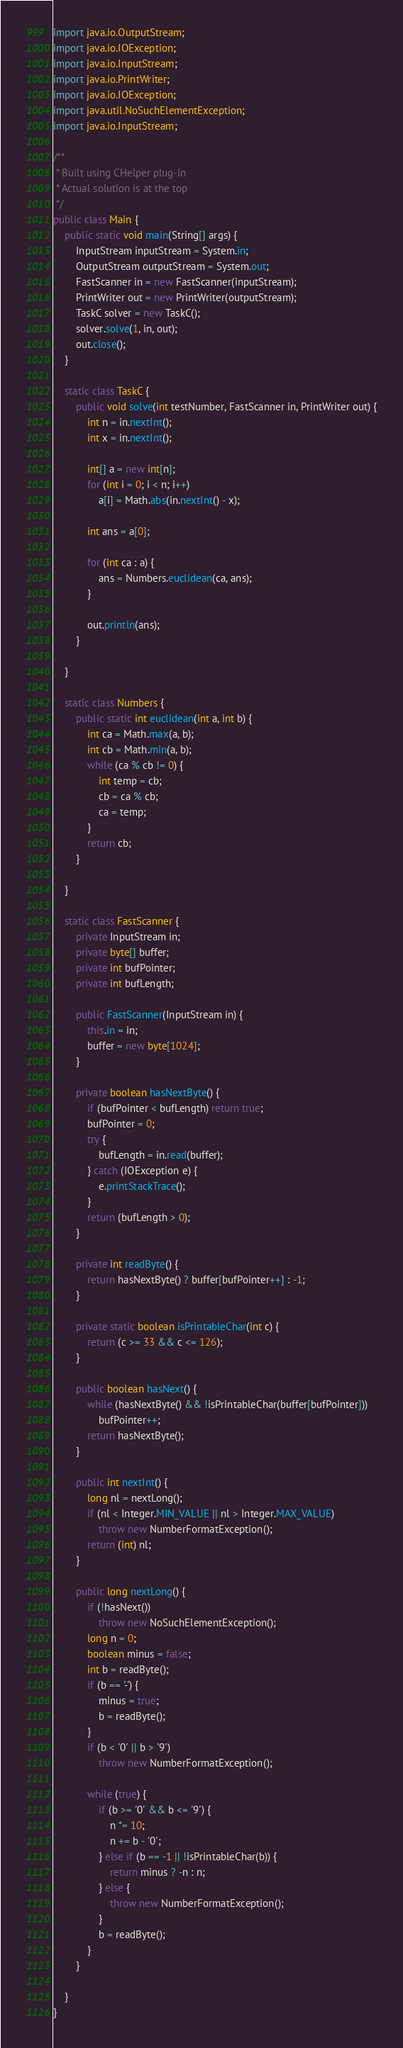<code> <loc_0><loc_0><loc_500><loc_500><_Java_>import java.io.OutputStream;
import java.io.IOException;
import java.io.InputStream;
import java.io.PrintWriter;
import java.io.IOException;
import java.util.NoSuchElementException;
import java.io.InputStream;

/**
 * Built using CHelper plug-in
 * Actual solution is at the top
 */
public class Main {
    public static void main(String[] args) {
        InputStream inputStream = System.in;
        OutputStream outputStream = System.out;
        FastScanner in = new FastScanner(inputStream);
        PrintWriter out = new PrintWriter(outputStream);
        TaskC solver = new TaskC();
        solver.solve(1, in, out);
        out.close();
    }

    static class TaskC {
        public void solve(int testNumber, FastScanner in, PrintWriter out) {
            int n = in.nextInt();
            int x = in.nextInt();

            int[] a = new int[n];
            for (int i = 0; i < n; i++)
                a[i] = Math.abs(in.nextInt() - x);

            int ans = a[0];

            for (int ca : a) {
                ans = Numbers.euclidean(ca, ans);
            }

            out.println(ans);
        }

    }

    static class Numbers {
        public static int euclidean(int a, int b) {
            int ca = Math.max(a, b);
            int cb = Math.min(a, b);
            while (ca % cb != 0) {
                int temp = cb;
                cb = ca % cb;
                ca = temp;
            }
            return cb;
        }

    }

    static class FastScanner {
        private InputStream in;
        private byte[] buffer;
        private int bufPointer;
        private int bufLength;

        public FastScanner(InputStream in) {
            this.in = in;
            buffer = new byte[1024];
        }

        private boolean hasNextByte() {
            if (bufPointer < bufLength) return true;
            bufPointer = 0;
            try {
                bufLength = in.read(buffer);
            } catch (IOException e) {
                e.printStackTrace();
            }
            return (bufLength > 0);
        }

        private int readByte() {
            return hasNextByte() ? buffer[bufPointer++] : -1;
        }

        private static boolean isPrintableChar(int c) {
            return (c >= 33 && c <= 126);
        }

        public boolean hasNext() {
            while (hasNextByte() && !isPrintableChar(buffer[bufPointer]))
                bufPointer++;
            return hasNextByte();
        }

        public int nextInt() {
            long nl = nextLong();
            if (nl < Integer.MIN_VALUE || nl > Integer.MAX_VALUE)
                throw new NumberFormatException();
            return (int) nl;
        }

        public long nextLong() {
            if (!hasNext())
                throw new NoSuchElementException();
            long n = 0;
            boolean minus = false;
            int b = readByte();
            if (b == '-') {
                minus = true;
                b = readByte();
            }
            if (b < '0' || b > '9')
                throw new NumberFormatException();

            while (true) {
                if (b >= '0' && b <= '9') {
                    n *= 10;
                    n += b - '0';
                } else if (b == -1 || !isPrintableChar(b)) {
                    return minus ? -n : n;
                } else {
                    throw new NumberFormatException();
                }
                b = readByte();
            }
        }

    }
}

</code> 